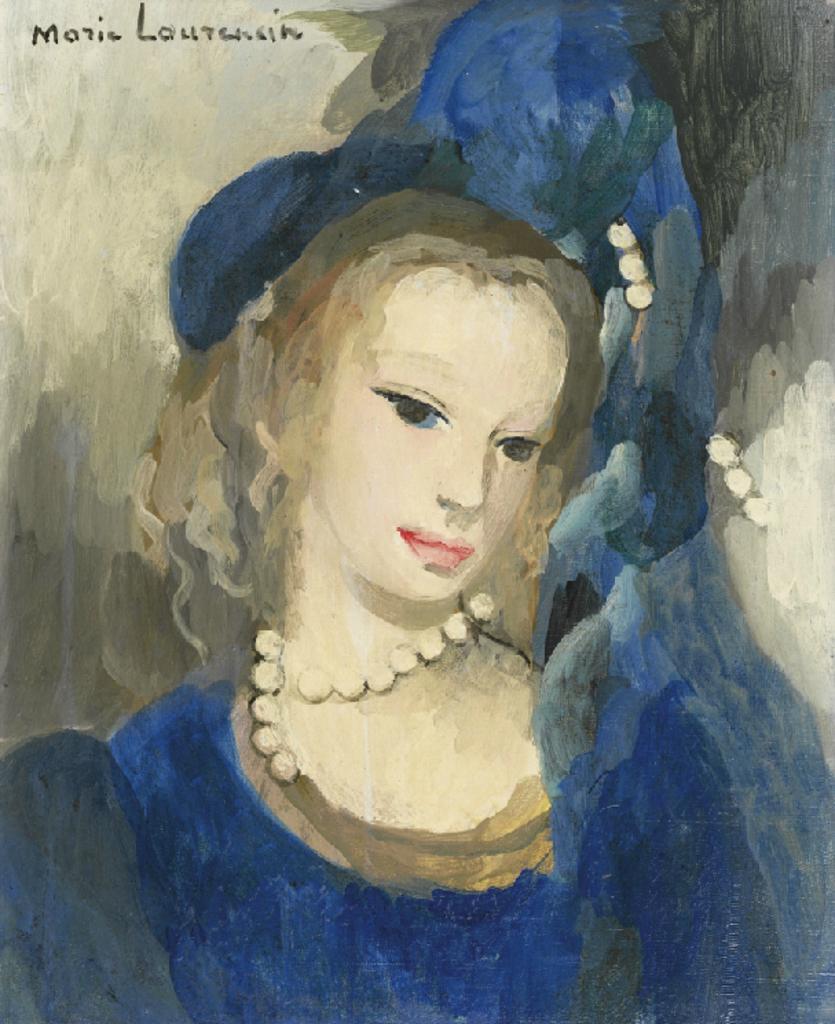Can you describe this image briefly? In this image we can see a painting of a woman and some text. 